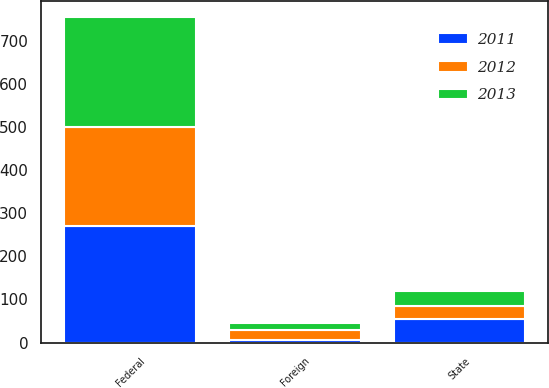Convert chart to OTSL. <chart><loc_0><loc_0><loc_500><loc_500><stacked_bar_chart><ecel><fcel>Federal<fcel>State<fcel>Foreign<nl><fcel>2012<fcel>231.6<fcel>29.9<fcel>22.5<nl><fcel>2013<fcel>254.1<fcel>35.1<fcel>16.9<nl><fcel>2011<fcel>269.7<fcel>54.3<fcel>6.8<nl></chart> 